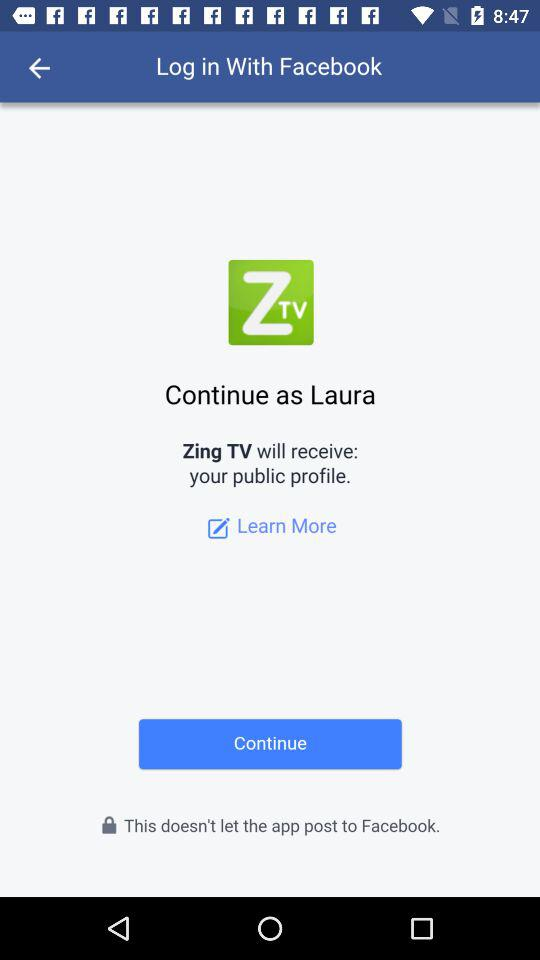What is the user name to continue the profile? The user name is Laura. 